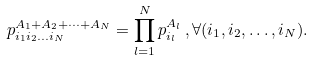Convert formula to latex. <formula><loc_0><loc_0><loc_500><loc_500>p _ { i _ { 1 } i _ { 2 } \dots i _ { N } } ^ { A _ { 1 } + A _ { 2 } + \dots + A _ { N } } = \prod _ { l = 1 } ^ { N } p _ { i _ { l } } ^ { A _ { l } } \, , \forall ( i _ { 1 } , i _ { 2 } , \dots , i _ { N } ) .</formula> 